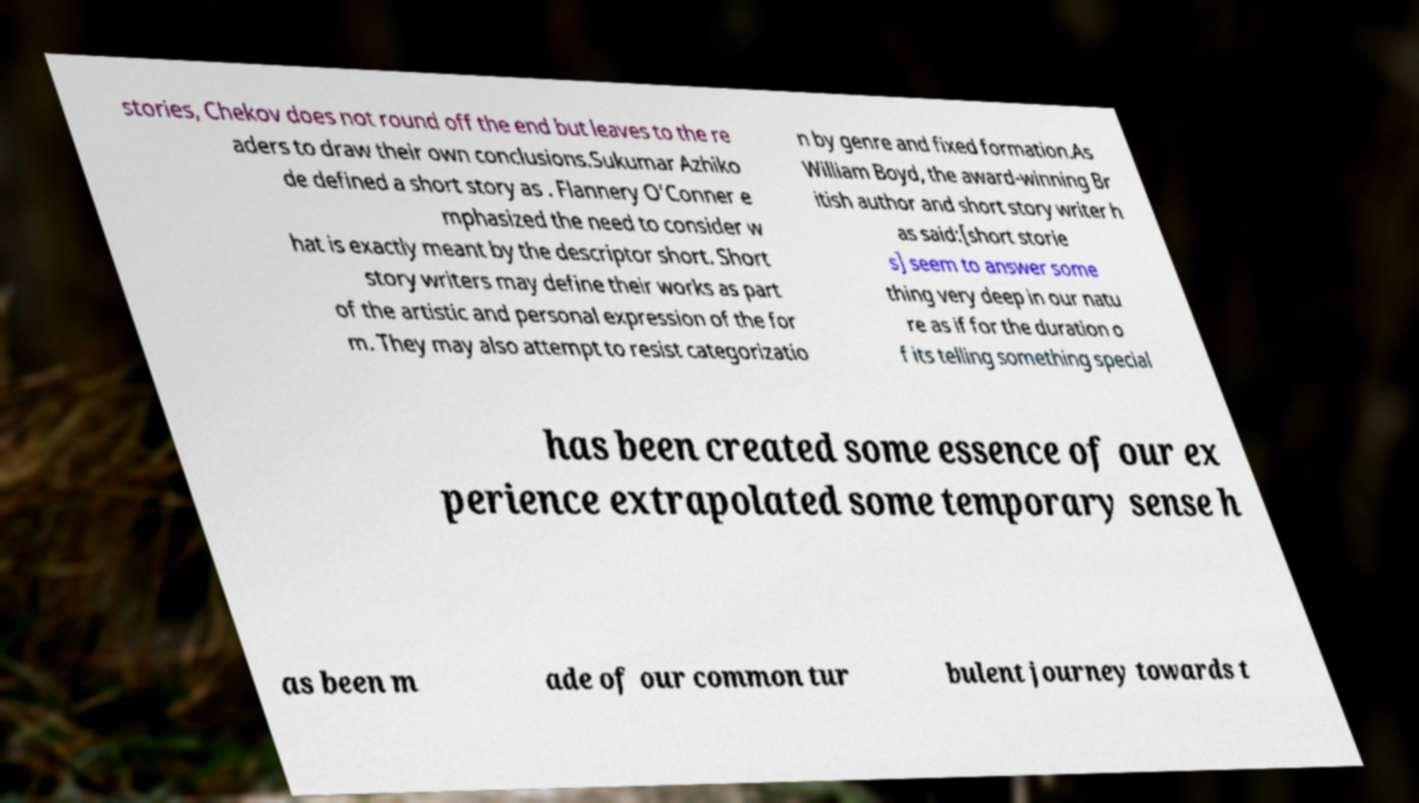For documentation purposes, I need the text within this image transcribed. Could you provide that? stories, Chekov does not round off the end but leaves to the re aders to draw their own conclusions.Sukumar Azhiko de defined a short story as . Flannery O'Conner e mphasized the need to consider w hat is exactly meant by the descriptor short. Short story writers may define their works as part of the artistic and personal expression of the for m. They may also attempt to resist categorizatio n by genre and fixed formation.As William Boyd, the award-winning Br itish author and short story writer h as said:[short storie s] seem to answer some thing very deep in our natu re as if for the duration o f its telling something special has been created some essence of our ex perience extrapolated some temporary sense h as been m ade of our common tur bulent journey towards t 